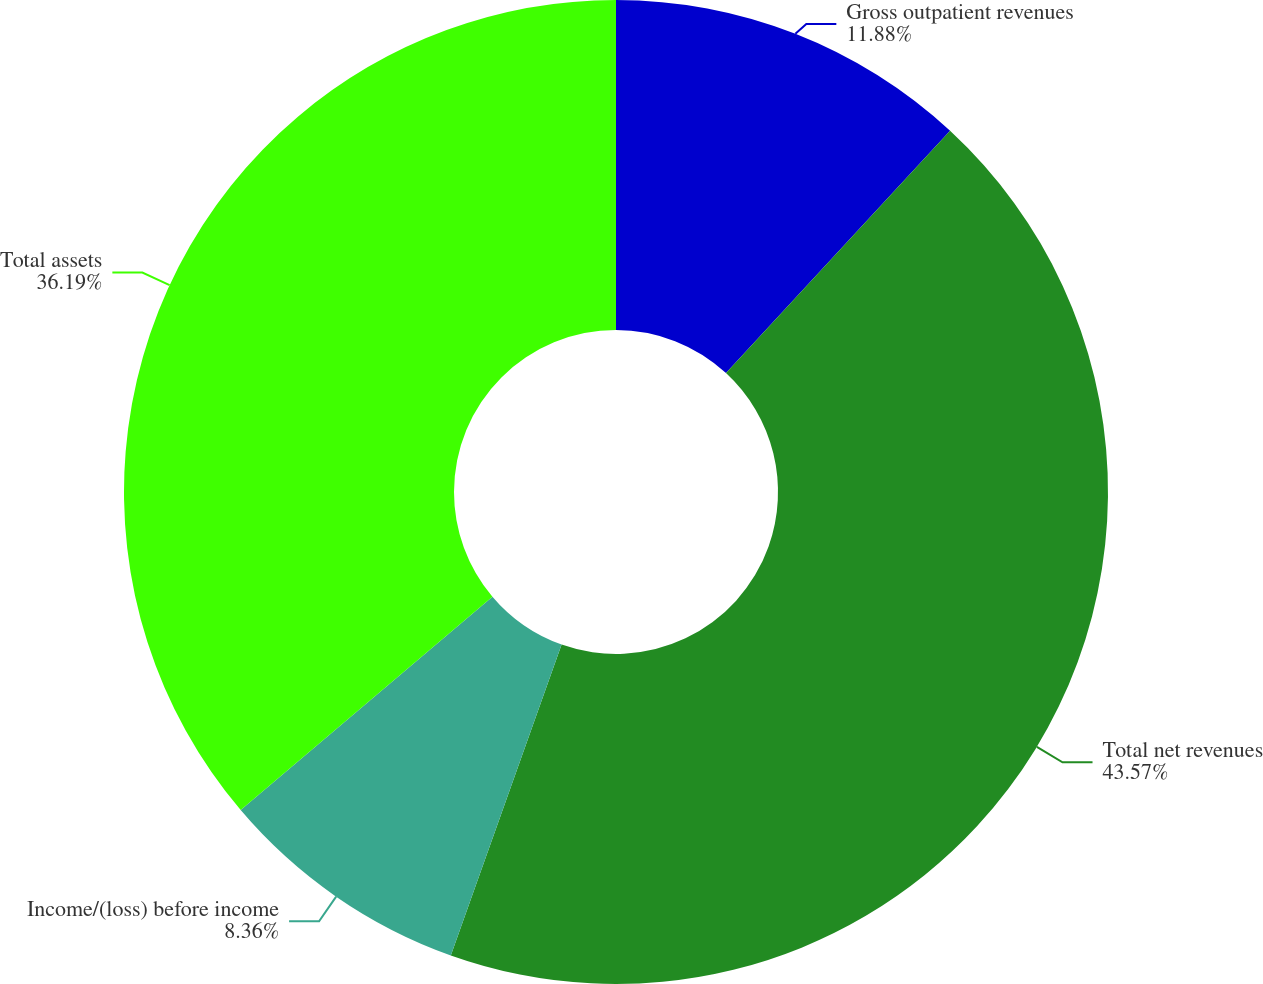<chart> <loc_0><loc_0><loc_500><loc_500><pie_chart><fcel>Gross outpatient revenues<fcel>Total net revenues<fcel>Income/(loss) before income<fcel>Total assets<nl><fcel>11.88%<fcel>43.57%<fcel>8.36%<fcel>36.19%<nl></chart> 